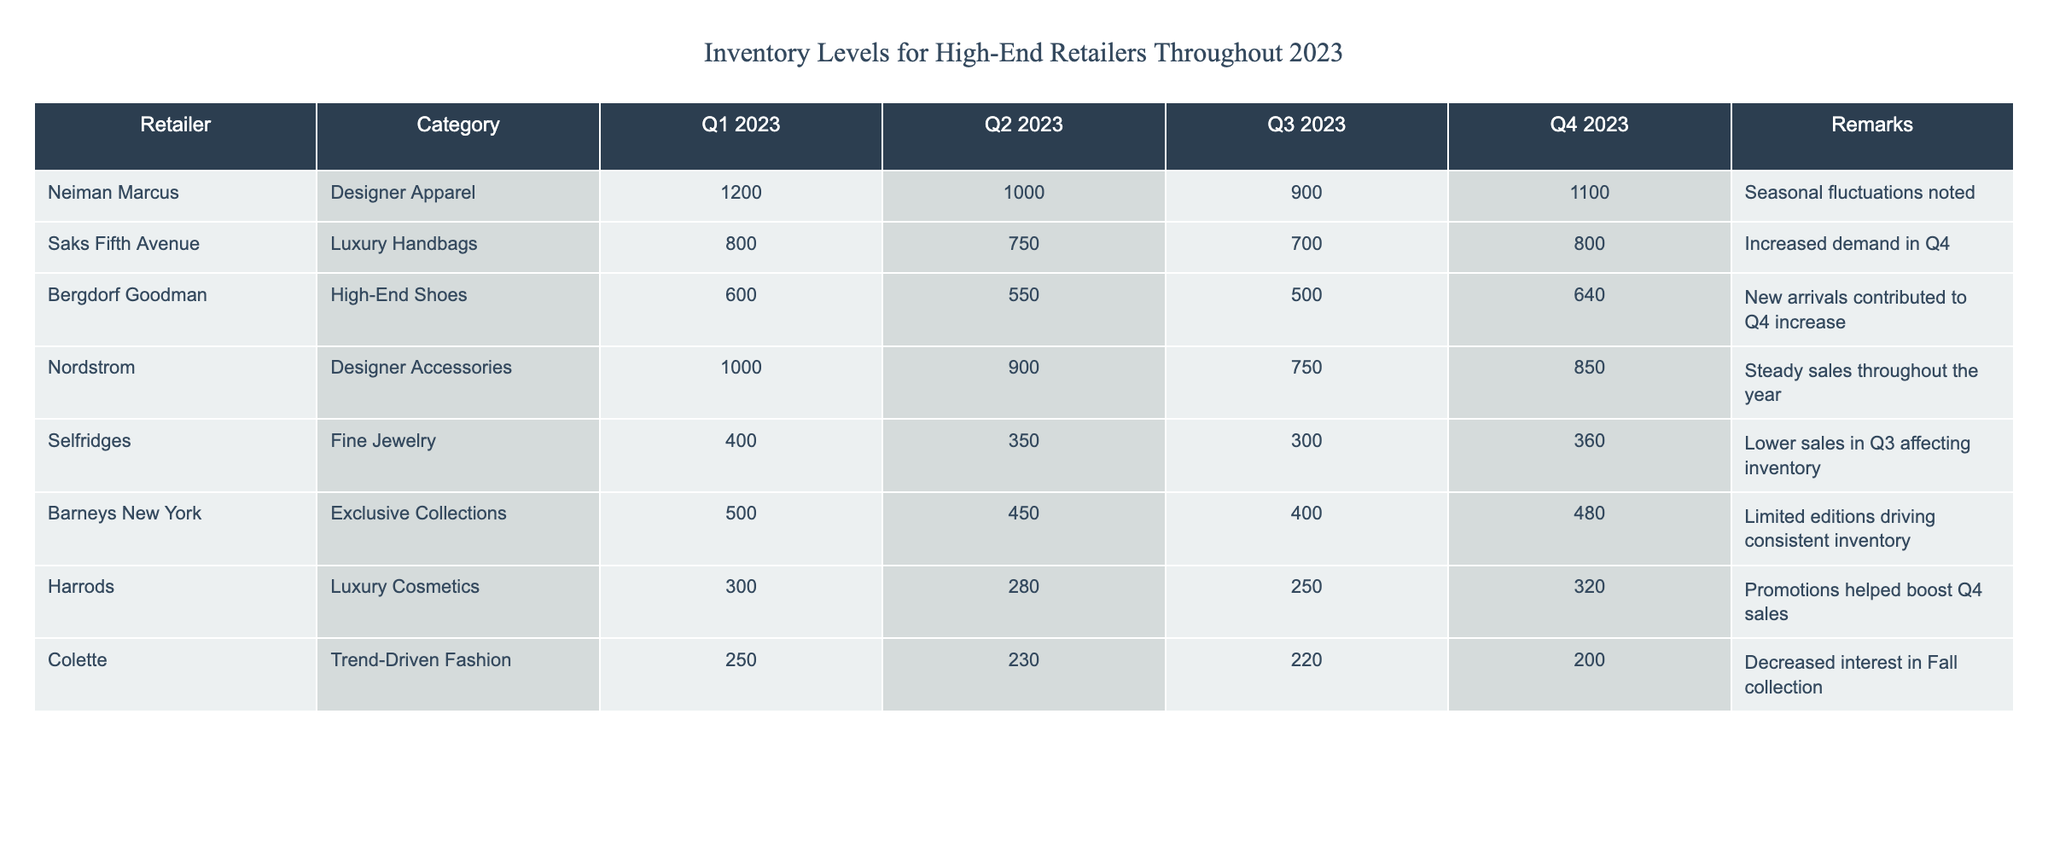What was the inventory level of Neiman Marcus in Q3 2023? The table indicates that Neiman Marcus had an inventory level of 900 units in Q3 2023.
Answer: 900 Which retailer had the highest inventory level in Q2 2023? In Q2 2023, Neiman Marcus had 1000 units, which is the highest among all retailers listed.
Answer: Neiman Marcus What was the total inventory level for Saks Fifth Avenue throughout 2023? Adding the inventory levels for Saks Fifth Avenue: 800 (Q1) + 750 (Q2) + 700 (Q3) + 800 (Q4) = 3050 units.
Answer: 3050 Was there an increase in the inventory level for Bergdorf Goodman from Q3 to Q4 2023? The inventory level for Bergdorf Goodman was 500 units in Q3 and increased to 640 units in Q4, indicating an increase.
Answer: Yes What was the average inventory level for Selfridges throughout the year? Summing up the inventory levels for Selfridges: 400 + 350 + 300 + 360 = 1410. Dividing by 4 (the number of quarters) gives an average of 1410/4 = 352.5.
Answer: 352.5 Which retailer experienced lower sales affecting inventory in Q3? The table indicates that Selfridges had lower sales in Q3, reflected in their inventory level of 300 units, which is the lowest in that quarter.
Answer: Selfridges How much did Barneys New York's inventory change from Q1 to Q4 2023? Barneys New York's inventory level dropped from 500 units in Q1 to 480 units in Q4, indicating a decrease of 20 units.
Answer: Decreased by 20 units In which quarter did Harrods have the lowest inventory level? The lowest inventory level for Harrods was 250 units in Q3 2023, as indicated in the table.
Answer: Q3 2023 What retailer saw a significant rise in inventory levels in Q4 2023 compared to Q3 2023? The inventory level for Bergdorf Goodman increased from 500 units in Q3 to 640 units in Q4, a notable rise of 140 units.
Answer: Bergdorf Goodman 